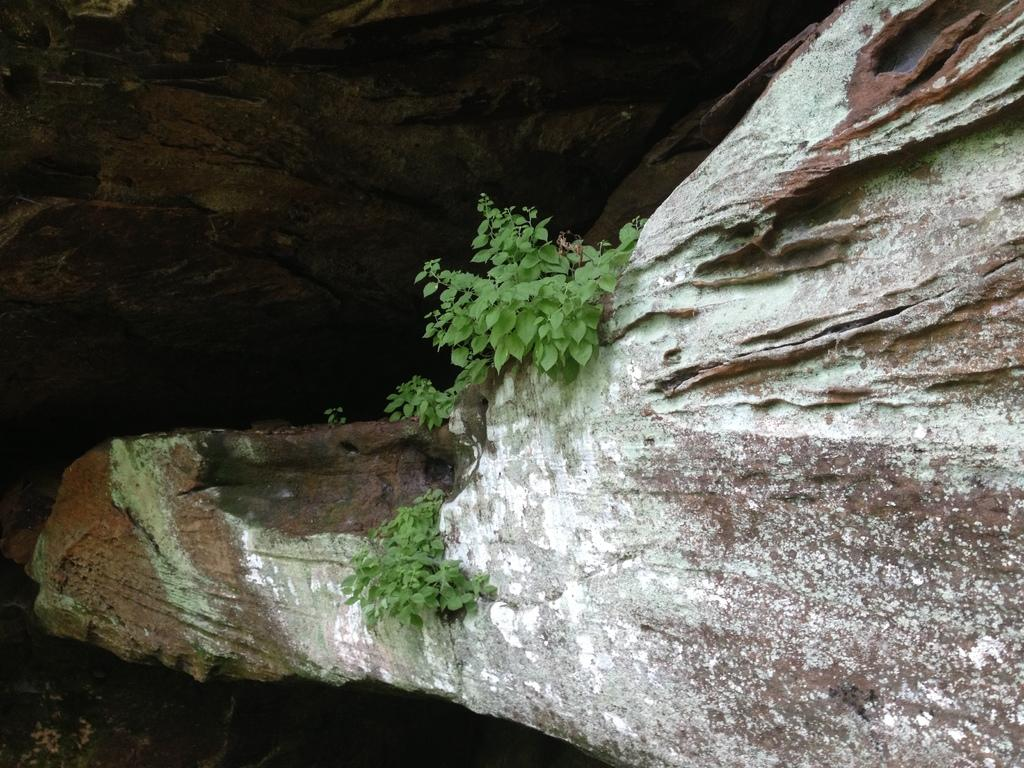What type of plant can be seen in the image? There is a tree in the image. What geological feature is present in the image? There is a rock in the image. What type of food is being cooked in the image? There is no food or cooking activity present in the image. How many items are being sorted in the image? There is no sorting activity present in the image. 